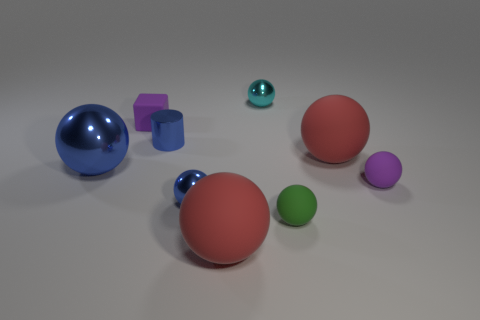What number of rubber objects are the same color as the rubber cube?
Your answer should be very brief. 1. There is a purple rubber object on the right side of the small cyan metal object; what size is it?
Provide a succinct answer. Small. There is a tiny purple rubber thing left of the purple matte thing that is in front of the big metallic sphere; what is its shape?
Provide a succinct answer. Cube. How many objects are left of the blue cylinder behind the big ball on the left side of the rubber cube?
Give a very brief answer. 2. Is the number of tiny metal balls behind the tiny blue shiny ball less than the number of small blue cylinders?
Offer a very short reply. No. Is there any other thing that has the same shape as the big blue thing?
Offer a terse response. Yes. There is a tiny purple matte thing on the left side of the tiny green sphere; what shape is it?
Your answer should be very brief. Cube. There is a rubber object to the left of the red rubber object on the left side of the big red thing that is on the right side of the green object; what shape is it?
Ensure brevity in your answer.  Cube. What number of things are small metal spheres or blue matte cubes?
Your answer should be very brief. 2. Is the shape of the blue thing behind the large blue shiny object the same as the big object in front of the tiny blue shiny ball?
Keep it short and to the point. No. 